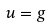Convert formula to latex. <formula><loc_0><loc_0><loc_500><loc_500>u = g \quad</formula> 